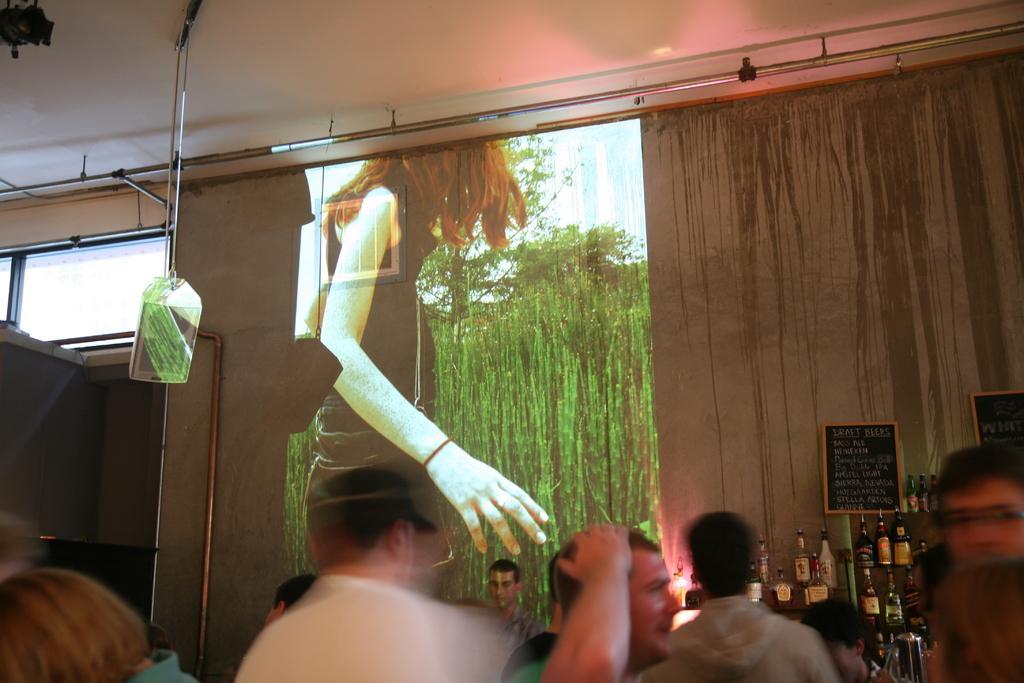Can you describe this image briefly? In the image we can see a projected screen and many people around. These are the bottles and a blackboard. 